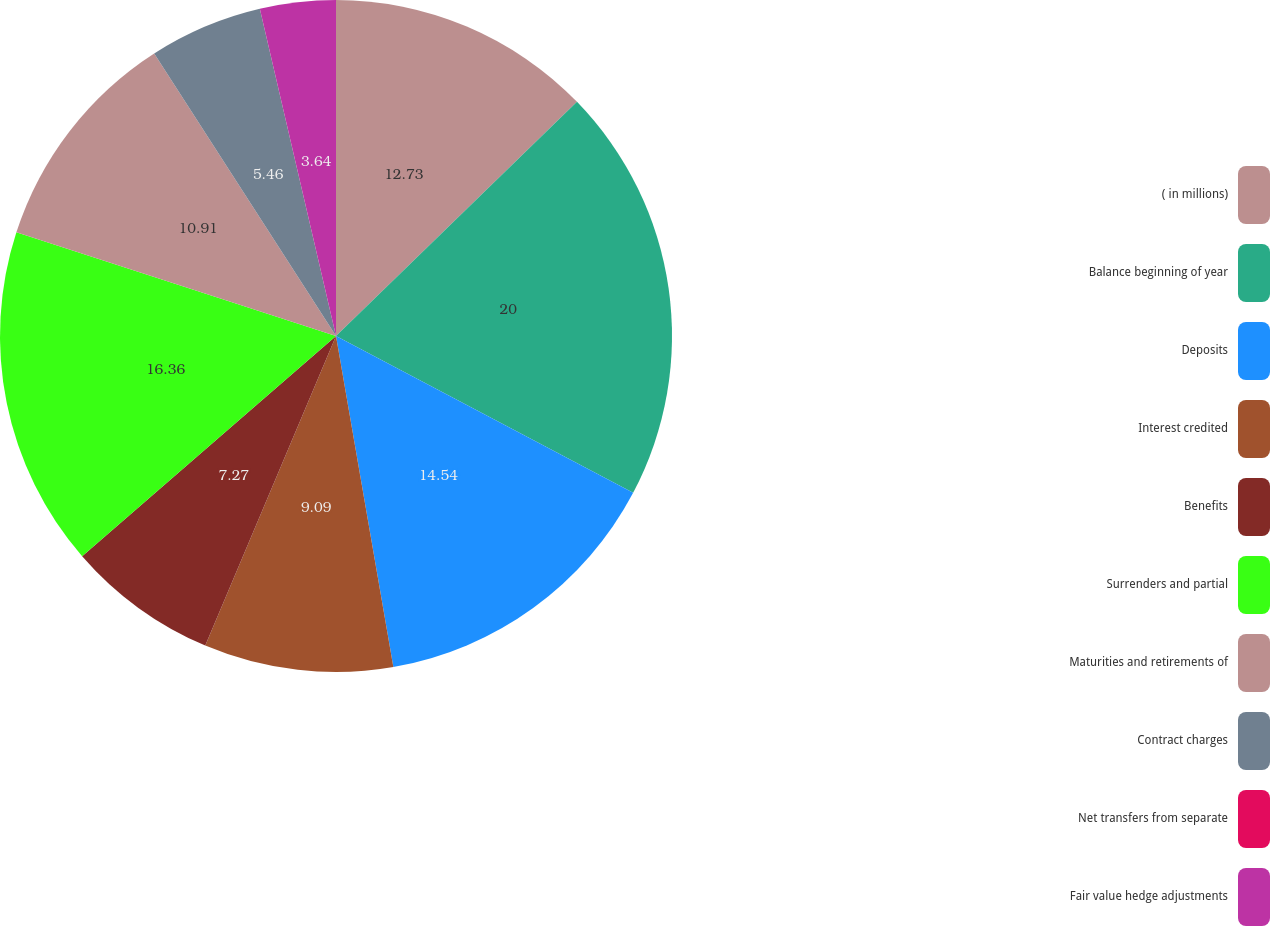Convert chart. <chart><loc_0><loc_0><loc_500><loc_500><pie_chart><fcel>( in millions)<fcel>Balance beginning of year<fcel>Deposits<fcel>Interest credited<fcel>Benefits<fcel>Surrenders and partial<fcel>Maturities and retirements of<fcel>Contract charges<fcel>Net transfers from separate<fcel>Fair value hedge adjustments<nl><fcel>12.73%<fcel>20.0%<fcel>14.54%<fcel>9.09%<fcel>7.27%<fcel>16.36%<fcel>10.91%<fcel>5.46%<fcel>0.0%<fcel>3.64%<nl></chart> 